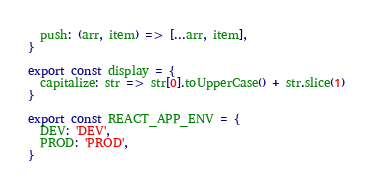<code> <loc_0><loc_0><loc_500><loc_500><_JavaScript_>  push: (arr, item) => [...arr, item],
}

export const display = {
  capitalize: str => str[0].toUpperCase() + str.slice(1)
}

export const REACT_APP_ENV = {
  DEV: 'DEV',
  PROD: 'PROD',
}</code> 